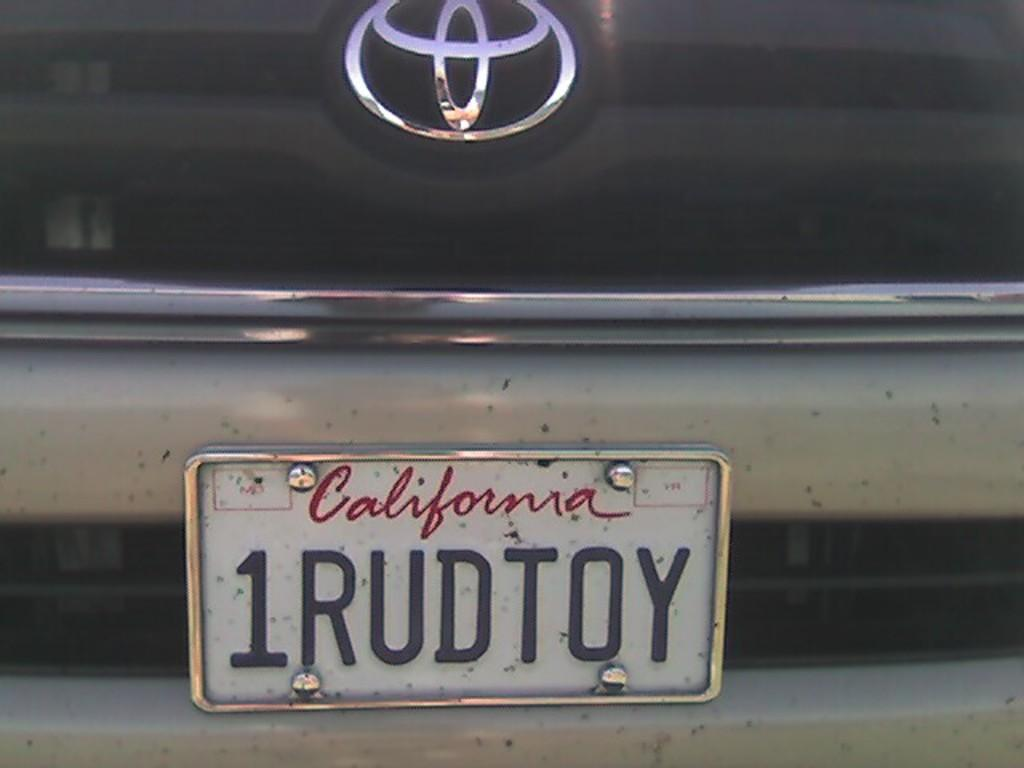<image>
Relay a brief, clear account of the picture shown. A Toyota with a license plate from California that says 1RUDTOY. 